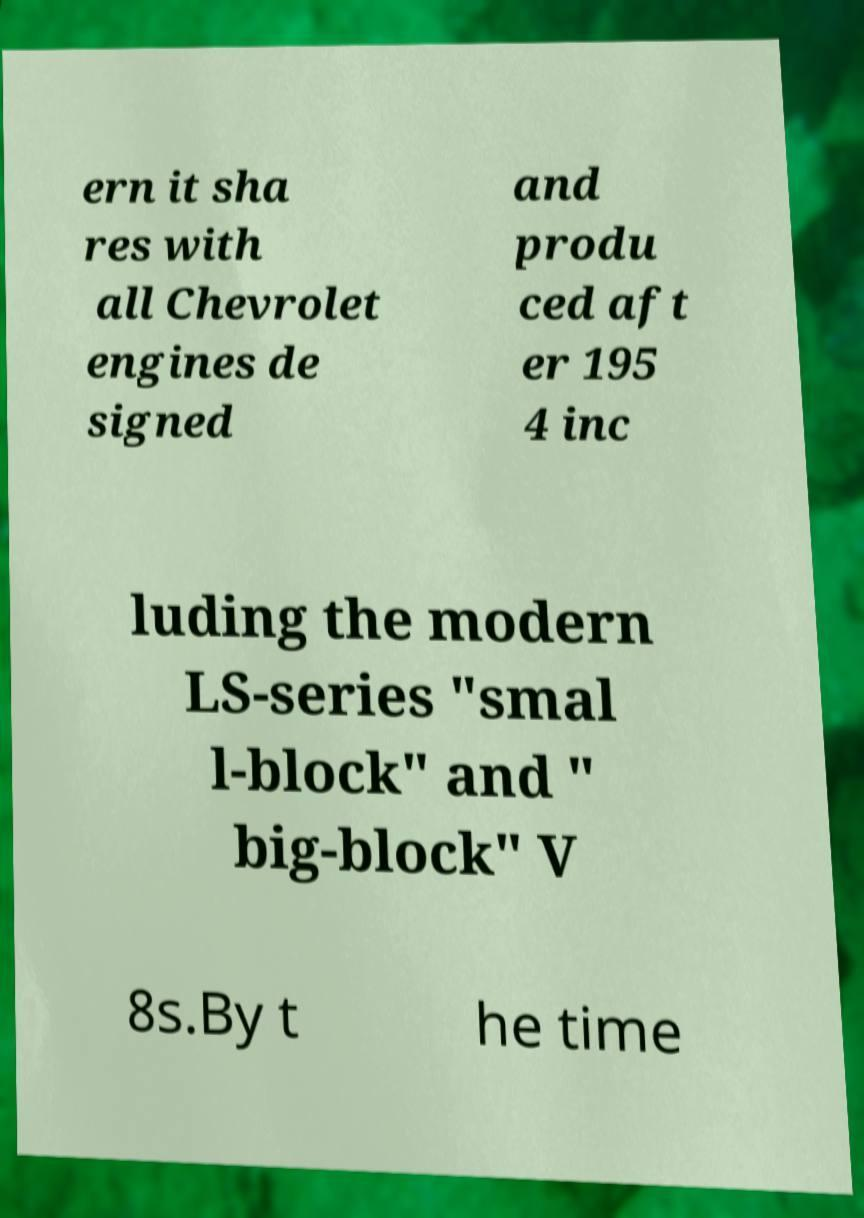Could you extract and type out the text from this image? ern it sha res with all Chevrolet engines de signed and produ ced aft er 195 4 inc luding the modern LS-series "smal l-block" and " big-block" V 8s.By t he time 